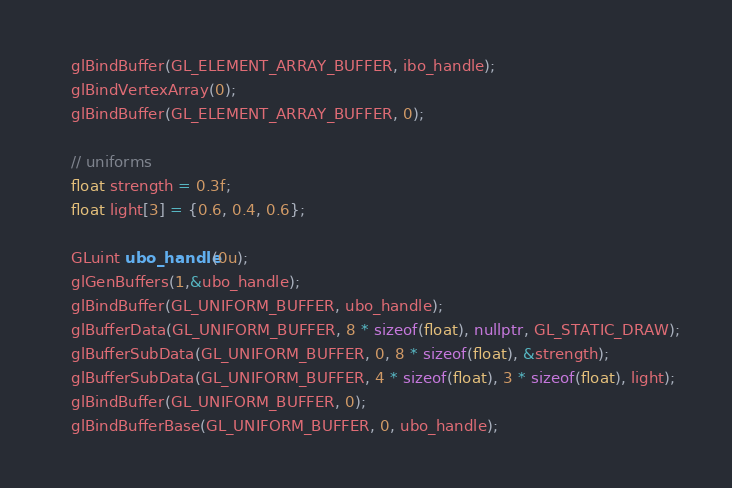Convert code to text. <code><loc_0><loc_0><loc_500><loc_500><_C++_>
    glBindBuffer(GL_ELEMENT_ARRAY_BUFFER, ibo_handle);
    glBindVertexArray(0);
    glBindBuffer(GL_ELEMENT_ARRAY_BUFFER, 0);

    // uniforms
    float strength = 0.3f;
    float light[3] = {0.6, 0.4, 0.6};

    GLuint ubo_handle(0u);
    glGenBuffers(1,&ubo_handle);
    glBindBuffer(GL_UNIFORM_BUFFER, ubo_handle);
    glBufferData(GL_UNIFORM_BUFFER, 8 * sizeof(float), nullptr, GL_STATIC_DRAW);
    glBufferSubData(GL_UNIFORM_BUFFER, 0, 8 * sizeof(float), &strength);
    glBufferSubData(GL_UNIFORM_BUFFER, 4 * sizeof(float), 3 * sizeof(float), light);
    glBindBuffer(GL_UNIFORM_BUFFER, 0);
    glBindBufferBase(GL_UNIFORM_BUFFER, 0, ubo_handle);


</code> 